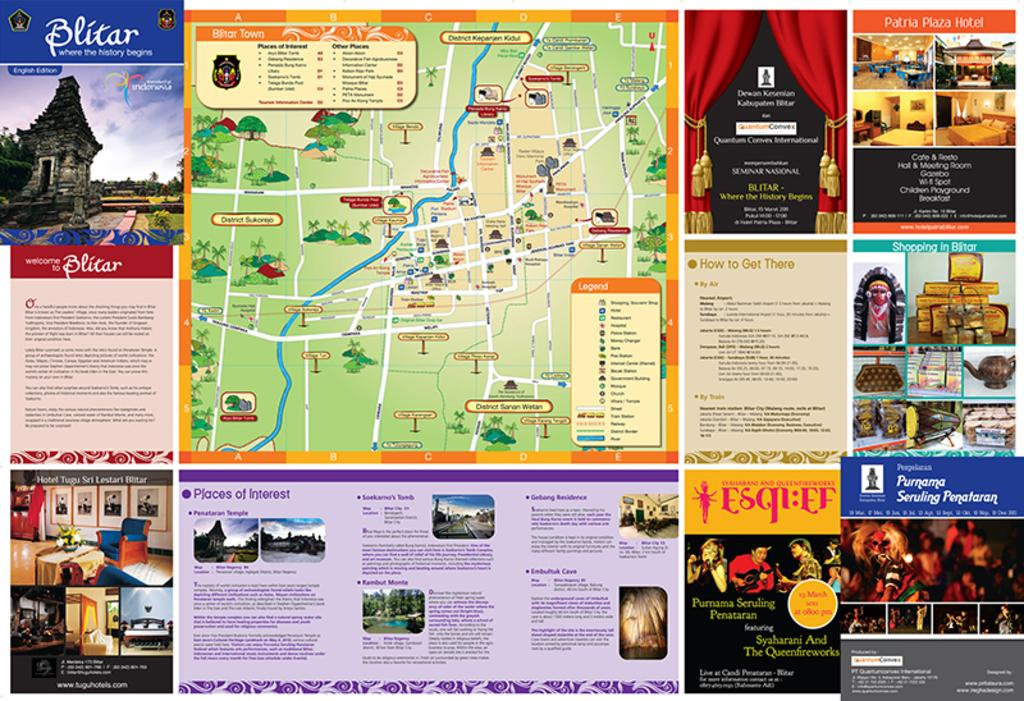<image>
Present a compact description of the photo's key features. it's a map of a theme park with information on it 